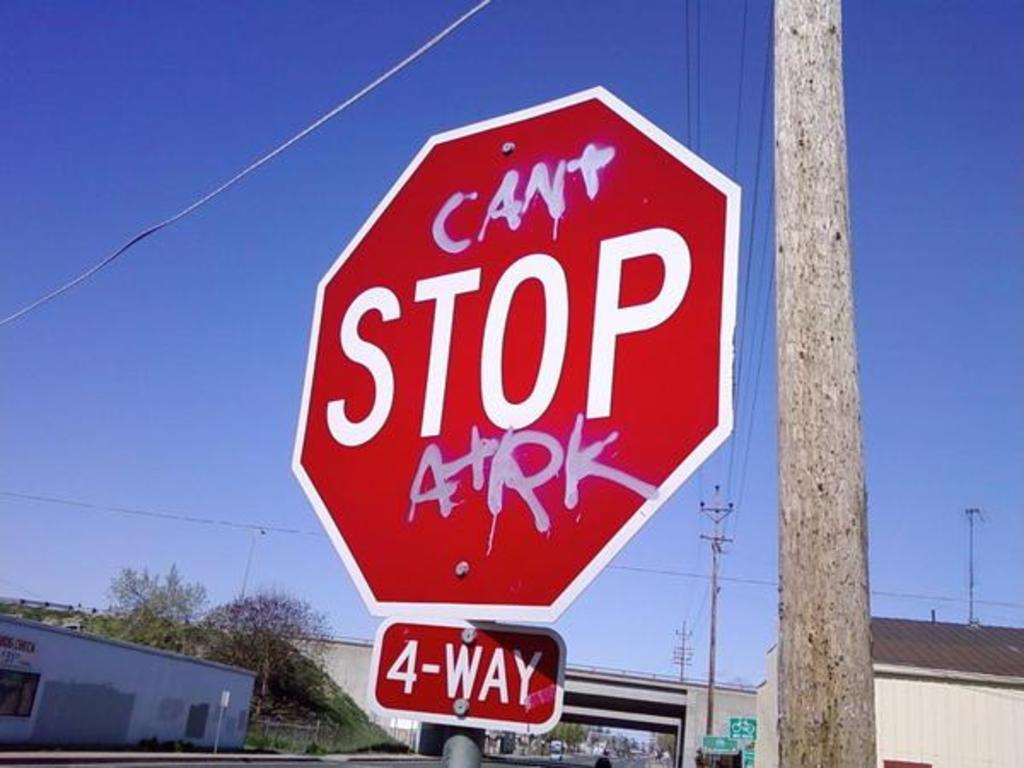<image>
Summarize the visual content of the image. A four way stop sign with the word can't in graffiti above the word stop. 